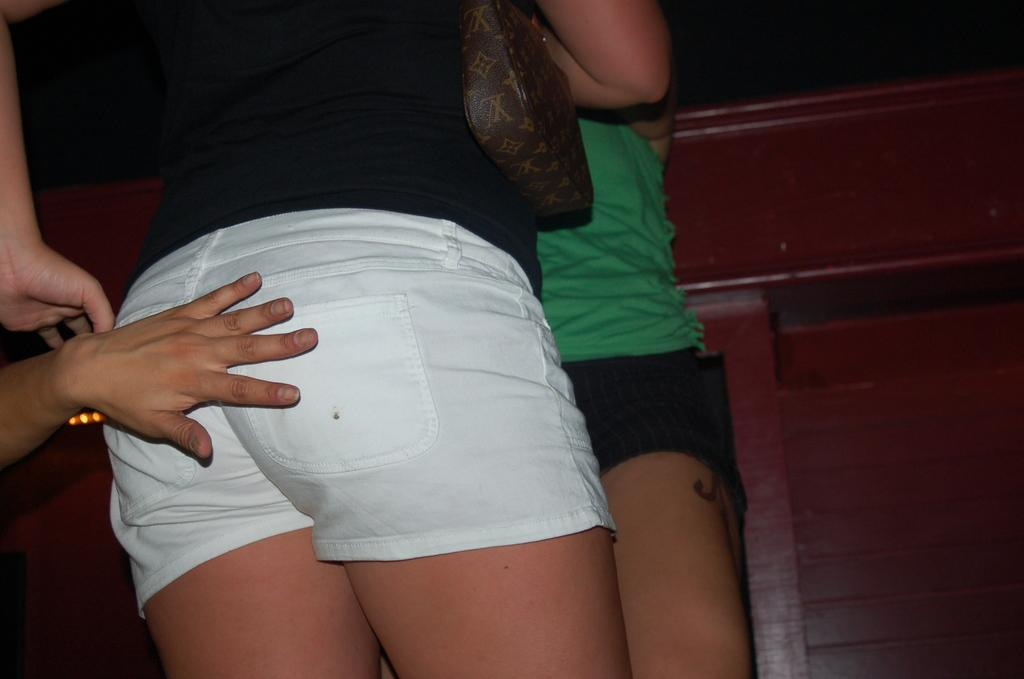How many people are present in the image? There are two persons standing in the image. Can you describe the hand visible on the left side of the image? There is a person's hand on the left side of the image. What type of object can be seen in the background of the image? There is a wooden object in the background of the image. What type of committee is meeting in the image? There is no committee meeting in the image; it only shows two people standing and a hand on the left side. What kind of waste can be seen in the image? There is no waste present in the image; it only features two people and a wooden object in the background. 